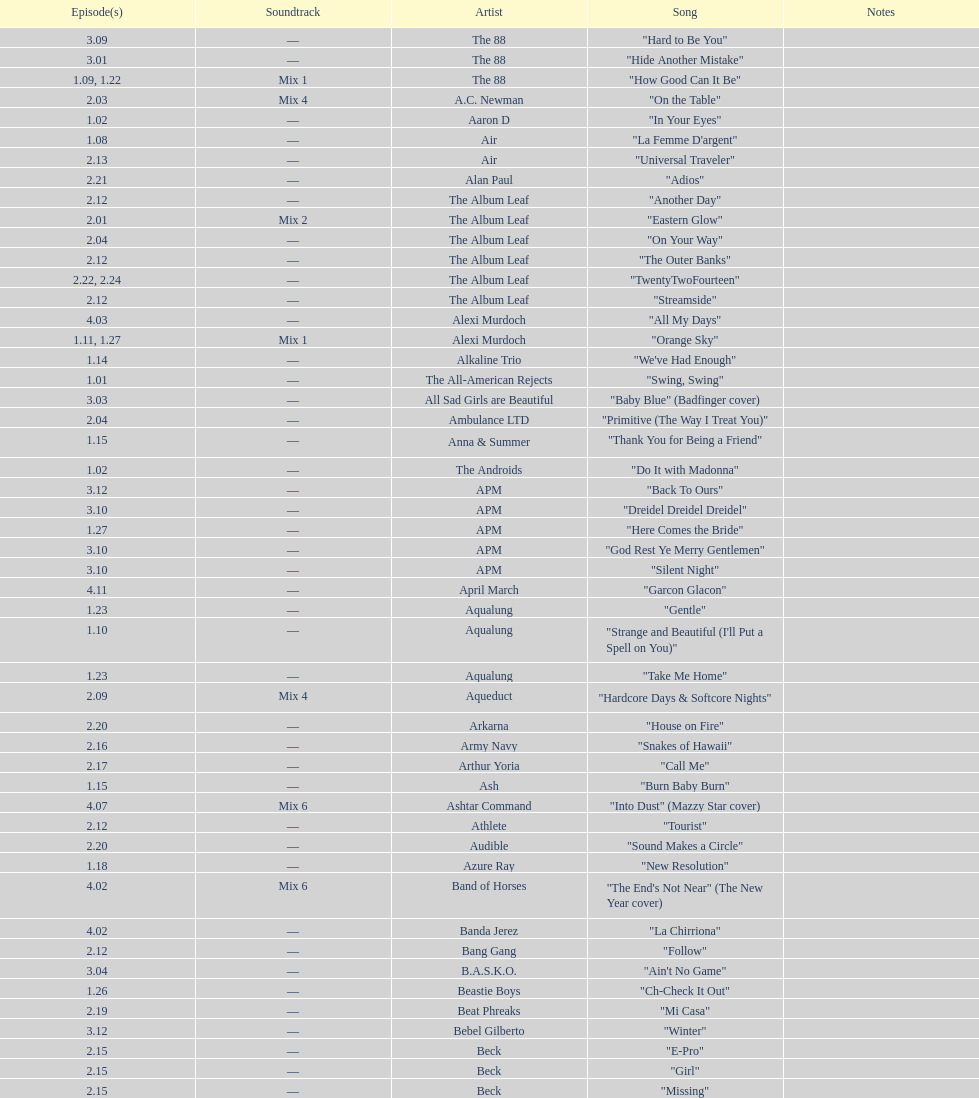"girl" and "el pro" were performed by which artist? Beck. 